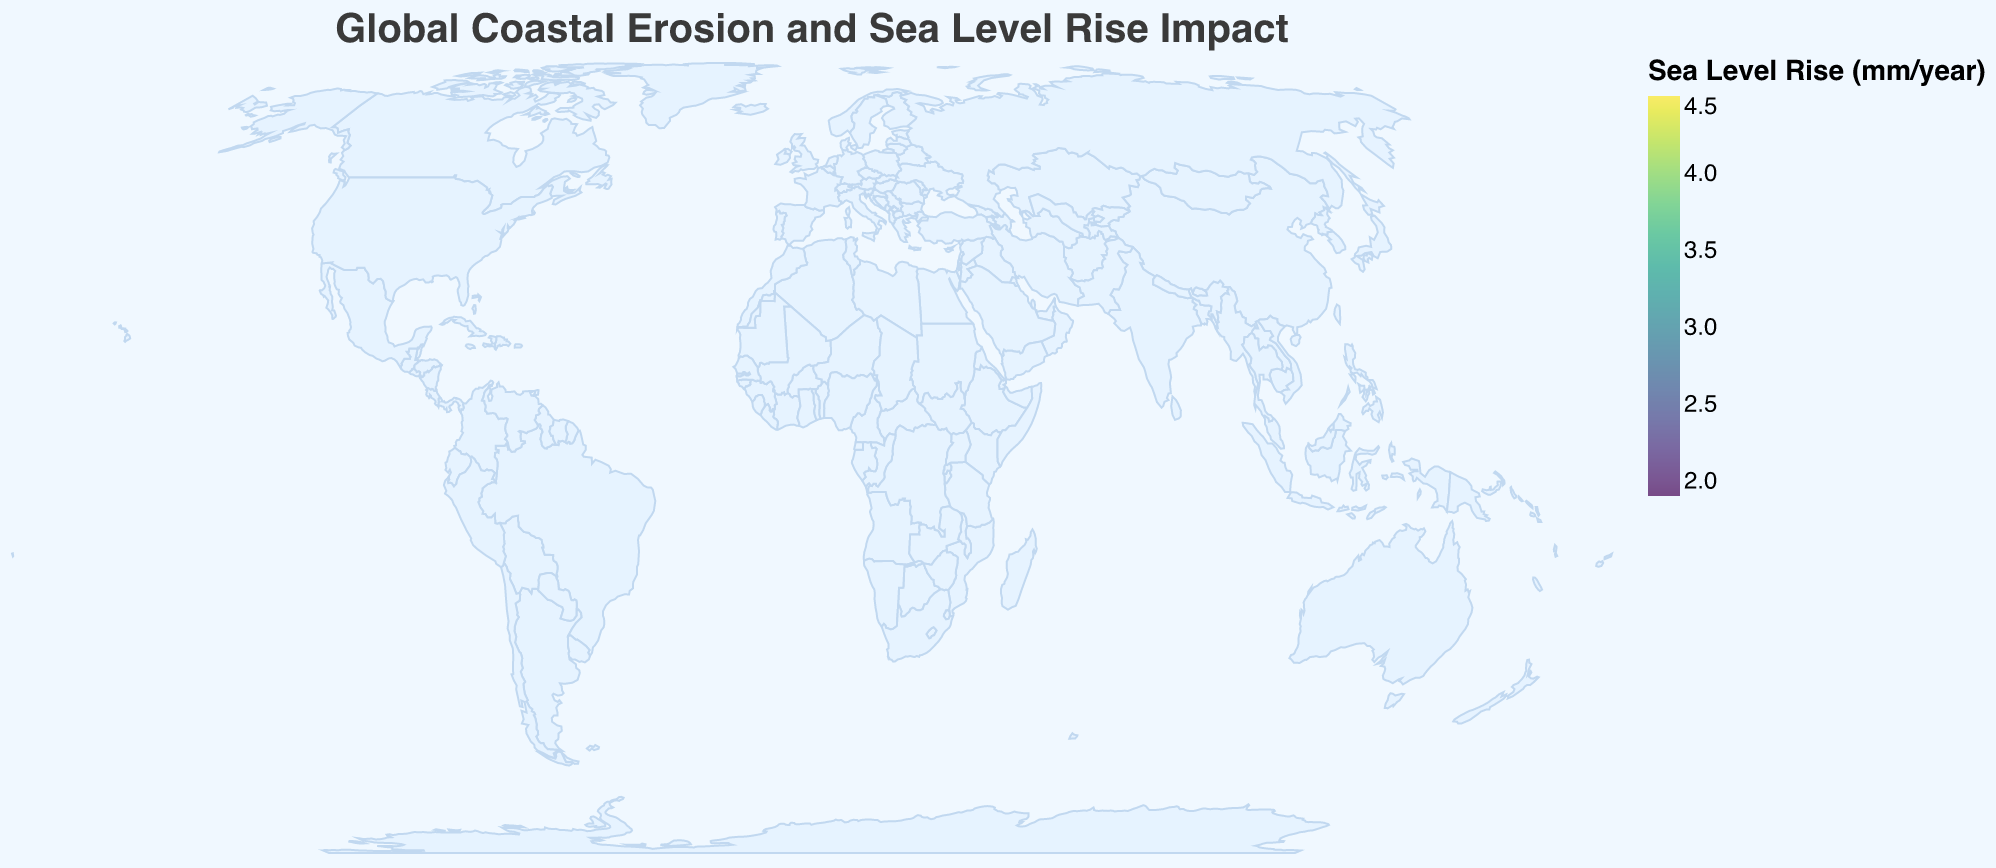What is the title of the figure? The title can be found at the top of the figure, which reads "Global Coastal Erosion and Sea Level Rise Impact".
Answer: Global Coastal Erosion and Sea Level Rise Impact How is the Erosion Rate visually represented in the figure? The erosion rate is represented by the size of the circles plotted on the map. Larger circles indicate higher erosion rates.
Answer: Size of the circles Which location has the highest Sea Level Rise rate and what is it? By examining the color of the circles, the location with the highest Sea Level Rise rate is Bangkok, marked by the darkest color on the viridis scale. The Sea Level Rise is 4.5 mm per year.
Answer: Bangkok, 4.5 mm/year Which type of coastline has the highest average Sea Level Rise rate? First, group the locations by coastline type and calculate the average Sea Level Rise rate for each type. Compare these averages to find the highest one.
- Sandy Beach: 3.4 -> 3.4
- Urban Coastline: 4.1 -> 4.1
- Artificial Islands: 2.8 -> 2.8
- Mixed Rocky and Sandy: 3.7 -> 3.7
- Reclaimed Land: 3.2 -> 3.2
- Coral Reef: 3.9 -> 3.9
- Rocky Cliffs: 1.9 -> 1.9
- Mangrove Forest: 4.5 -> 4.5
- Bay Coastline: 3.1 -> 3.1
- Estuarine: 3.8 -> 3.8
- Island Cluster: 3.0 -> 3.0
- Mixed Urban and Natural: 2.7 -> 2.7
- Mediterranean Coast: 2.5 -> 2.5
The highest average is for Mangrove Forest at 4.5 mm/year.
Answer: Mangrove Forest Which location has the lowest erosion rate and what is it? By looking at the size of the circles, the smallest circle corresponds to Singapore, with an erosion rate of 0.1 m per year.
Answer: Singapore, 0.1 m/year Compare the erosion rates of Sydney and New York City. Which one has a higher rate and by how much? Sydney has an erosion rate of 0.3 m/year and New York City has 0.5 m/year. Subtract Sydney's rate from New York City's to find the difference: 0.5 - 0.3 = 0.2.
Answer: New York City, 0.2 m/year Is there a correlation between Erosion Rate and Sea Level Rise rate? To determine if there's a correlation, observe the circles' sizes and colors. If larger circles consistently have darker colors or smaller circles have lighter colors, a correlation might be present. Generally, there is an observable pattern where higher erosion rates (larger circles) are associated with higher sea level rise rates (darker colors), suggesting a correlation.
Answer: Yes What coastline type is represented by the circle located at approximately 25°N latitude and 51°E longitude? The figure shows a circle at 25.2867°N latitude and 51.5333°E longitude (Doha) representing the "Artificial Islands" coastline type.
Answer: Artificial Islands 